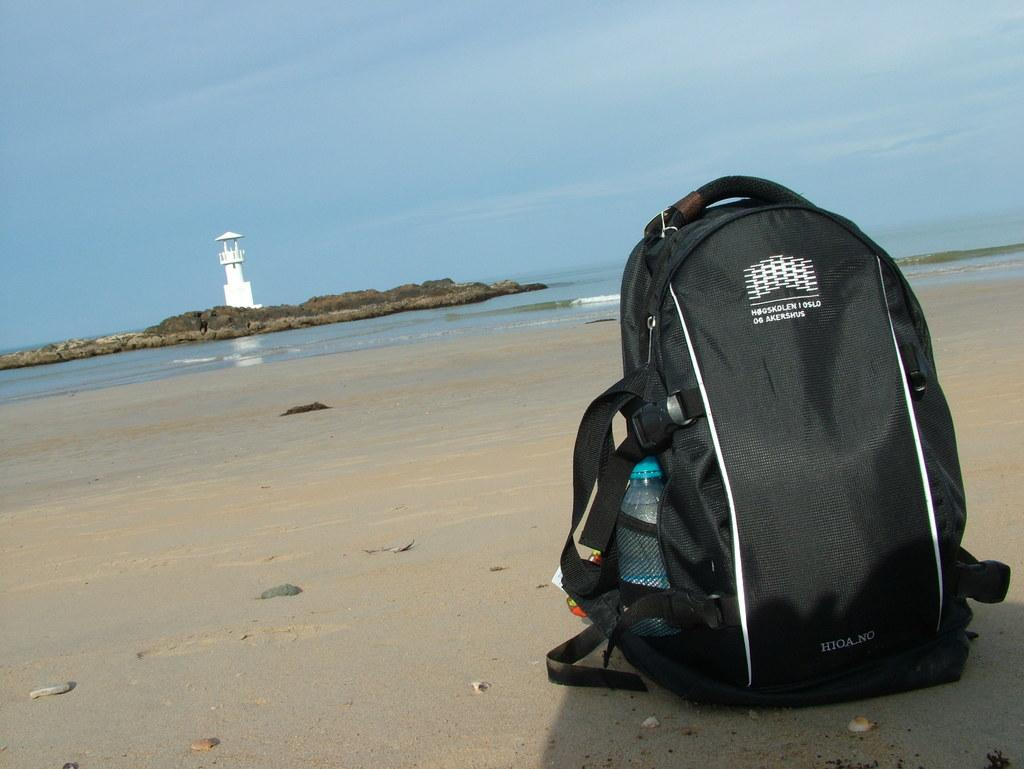<image>
Present a compact description of the photo's key features. a black backpack that says 'hogskolen 1 oslo og akershus' on it 